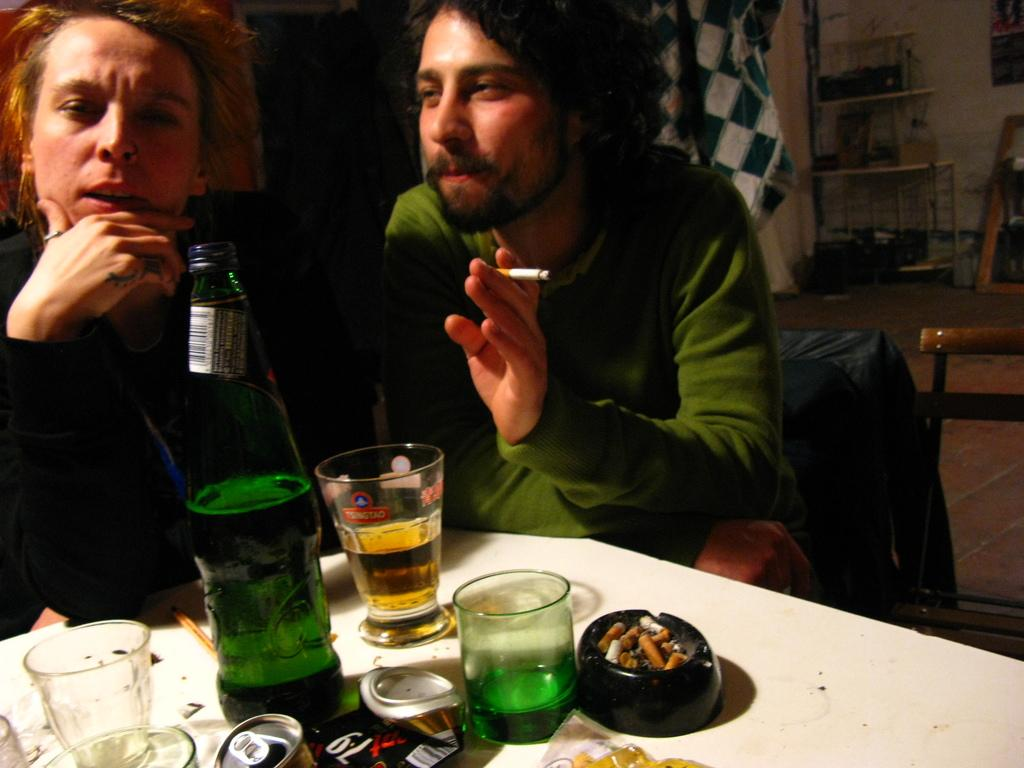Who are the people in the image? There is a man and a woman in the image. What is the man holding in the image? The man is holding a cigarette. What objects can be seen on the table in the image? There is a bottle and glasses on the table in the image. What type of wheel can be seen in the image? There is no wheel present in the image. How does the woman express disgust in the image? The image does not show any expression of disgust from the woman. 